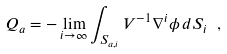<formula> <loc_0><loc_0><loc_500><loc_500>Q _ { a } = - \lim _ { i \to \infty } \int _ { S _ { a , i } } V ^ { - 1 } \nabla ^ { i } \phi \, d S _ { i } \ ,</formula> 